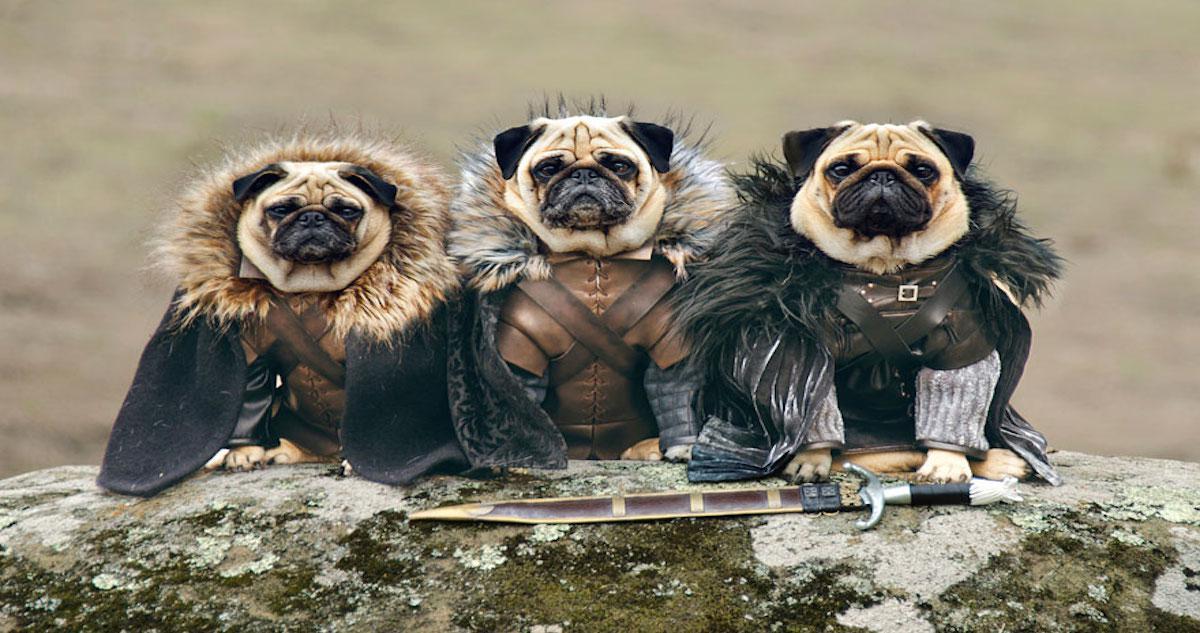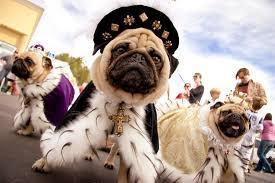The first image is the image on the left, the second image is the image on the right. Evaluate the accuracy of this statement regarding the images: "There is at least one pug dog in the center of both images.". Is it true? Answer yes or no. Yes. The first image is the image on the left, the second image is the image on the right. Examine the images to the left and right. Is the description "Each image contains a trio of pugs and includes at least two beige pugs with dark muzzles." accurate? Answer yes or no. Yes. 